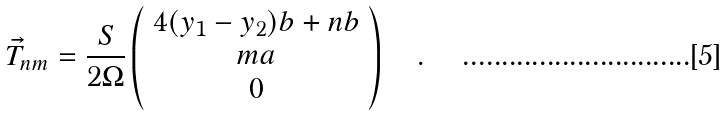Convert formula to latex. <formula><loc_0><loc_0><loc_500><loc_500>\vec { T } _ { n m } = \frac { S } { 2 \Omega } \left ( \begin{array} { c } 4 ( y _ { 1 } - y _ { 2 } ) b + n b \\ m a \\ 0 \end{array} \right ) \quad .</formula> 